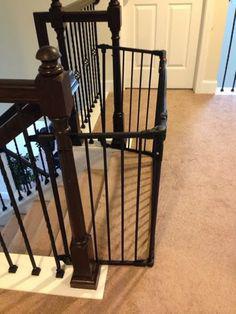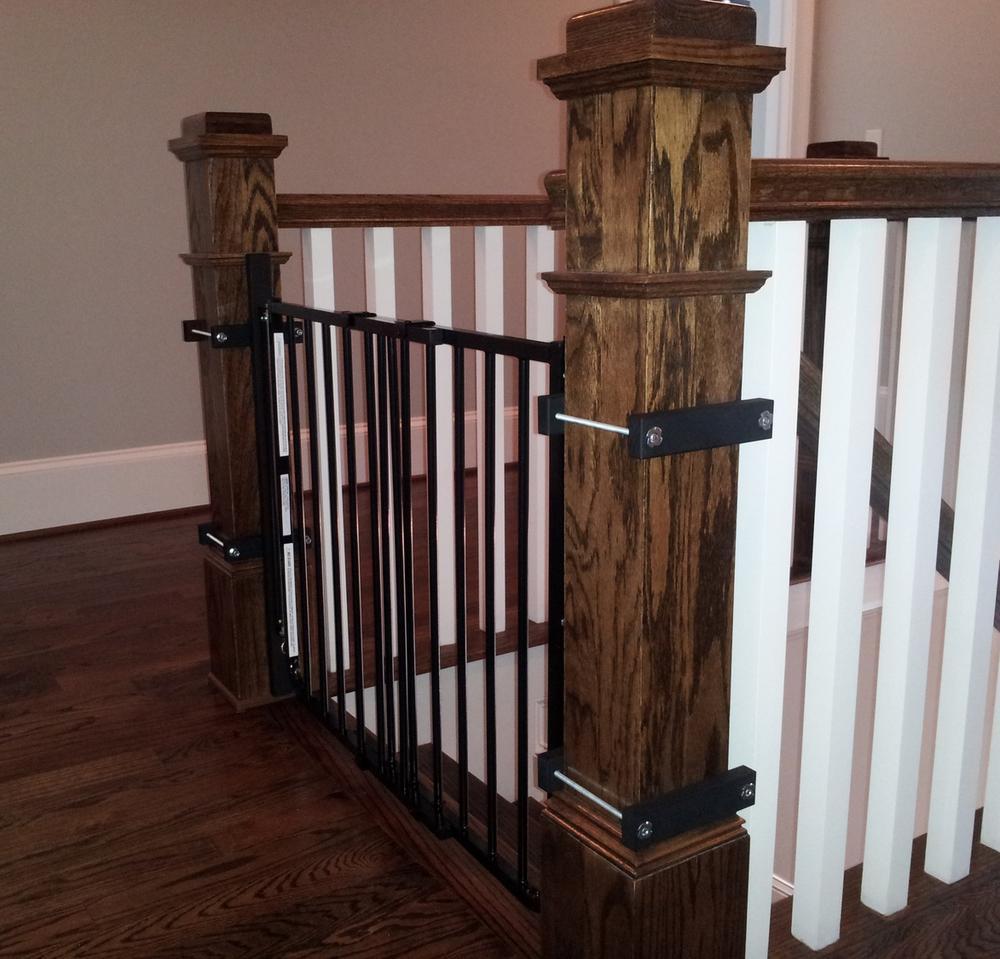The first image is the image on the left, the second image is the image on the right. Analyze the images presented: Is the assertion "The stairway posts are all dark wood." valid? Answer yes or no. Yes. The first image is the image on the left, the second image is the image on the right. For the images displayed, is the sentence "Some of the floors upstairs are not carpeted." factually correct? Answer yes or no. Yes. 